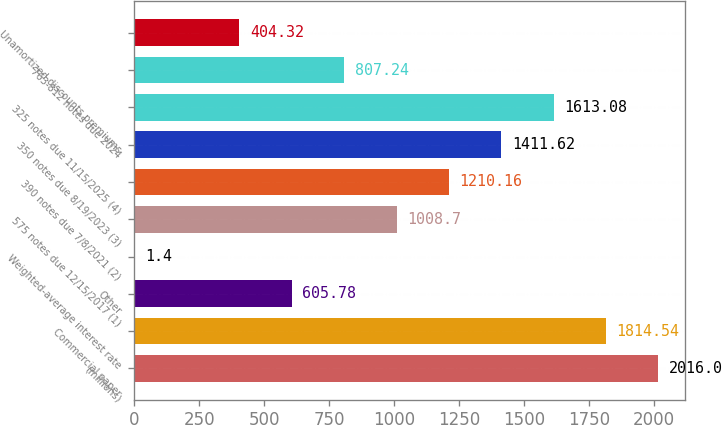<chart> <loc_0><loc_0><loc_500><loc_500><bar_chart><fcel>(millions)<fcel>Commercial paper<fcel>Other<fcel>Weighted-average interest rate<fcel>575 notes due 12/15/2017 (1)<fcel>390 notes due 7/8/2021 (2)<fcel>350 notes due 8/19/2023 (3)<fcel>325 notes due 11/15/2025 (4)<fcel>763-812 notes due 2024<fcel>Unamortized discounts premiums<nl><fcel>2016<fcel>1814.54<fcel>605.78<fcel>1.4<fcel>1008.7<fcel>1210.16<fcel>1411.62<fcel>1613.08<fcel>807.24<fcel>404.32<nl></chart> 